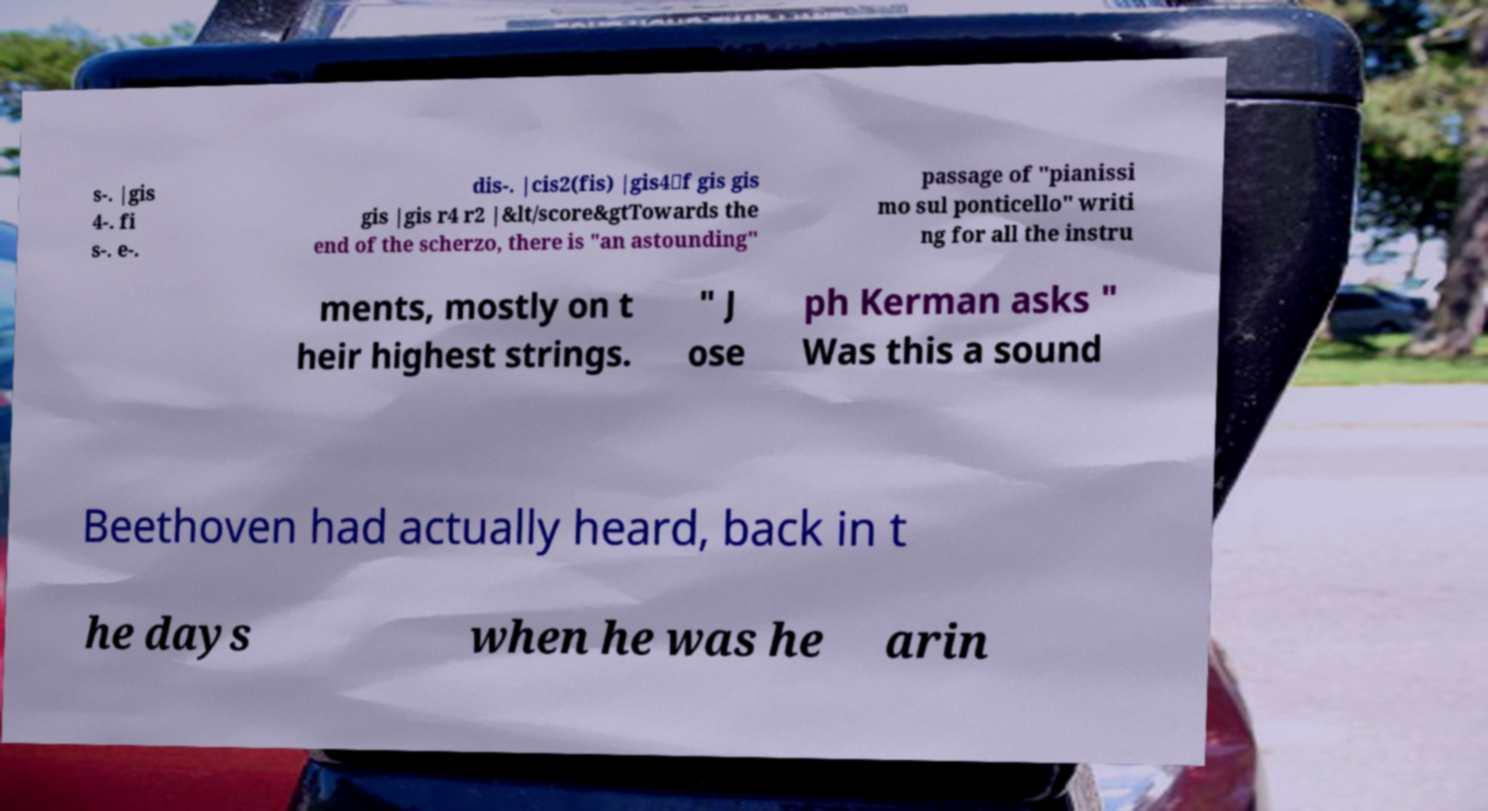There's text embedded in this image that I need extracted. Can you transcribe it verbatim? s-. |gis 4-. fi s-. e-. dis-. |cis2(fis) |gis4\f gis gis gis |gis r4 r2 |&lt/score&gtTowards the end of the scherzo, there is "an astounding" passage of "pianissi mo sul ponticello" writi ng for all the instru ments, mostly on t heir highest strings. " J ose ph Kerman asks " Was this a sound Beethoven had actually heard, back in t he days when he was he arin 